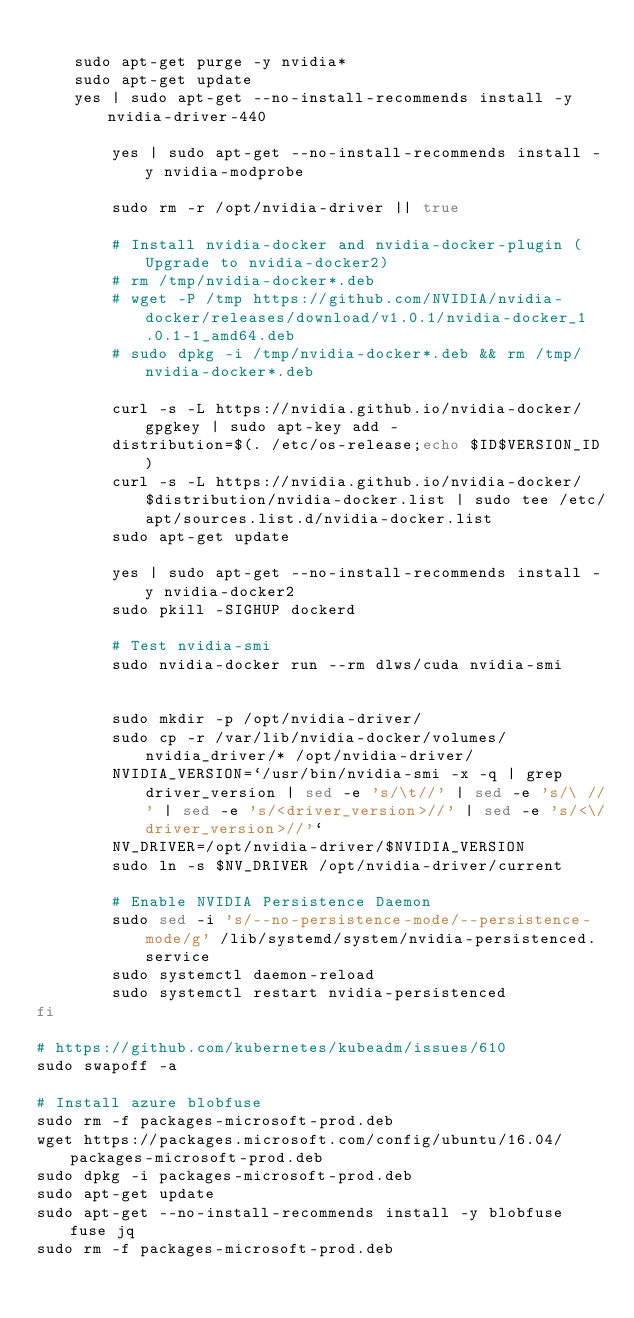<code> <loc_0><loc_0><loc_500><loc_500><_Bash_>
    sudo apt-get purge -y nvidia*
    sudo apt-get update
    yes | sudo apt-get --no-install-recommends install -y nvidia-driver-440

        yes | sudo apt-get --no-install-recommends install -y nvidia-modprobe

        sudo rm -r /opt/nvidia-driver || true

        # Install nvidia-docker and nvidia-docker-plugin ( Upgrade to nvidia-docker2)
        # rm /tmp/nvidia-docker*.deb
        # wget -P /tmp https://github.com/NVIDIA/nvidia-docker/releases/download/v1.0.1/nvidia-docker_1.0.1-1_amd64.deb
        # sudo dpkg -i /tmp/nvidia-docker*.deb && rm /tmp/nvidia-docker*.deb

        curl -s -L https://nvidia.github.io/nvidia-docker/gpgkey | sudo apt-key add -
        distribution=$(. /etc/os-release;echo $ID$VERSION_ID)
        curl -s -L https://nvidia.github.io/nvidia-docker/$distribution/nvidia-docker.list | sudo tee /etc/apt/sources.list.d/nvidia-docker.list
        sudo apt-get update

        yes | sudo apt-get --no-install-recommends install -y nvidia-docker2
        sudo pkill -SIGHUP dockerd

        # Test nvidia-smi
        sudo nvidia-docker run --rm dlws/cuda nvidia-smi


        sudo mkdir -p /opt/nvidia-driver/
        sudo cp -r /var/lib/nvidia-docker/volumes/nvidia_driver/* /opt/nvidia-driver/
        NVIDIA_VERSION=`/usr/bin/nvidia-smi -x -q | grep driver_version | sed -e 's/\t//' | sed -e 's/\ //' | sed -e 's/<driver_version>//' | sed -e 's/<\/driver_version>//'`
        NV_DRIVER=/opt/nvidia-driver/$NVIDIA_VERSION
        sudo ln -s $NV_DRIVER /opt/nvidia-driver/current

        # Enable NVIDIA Persistence Daemon
        sudo sed -i 's/--no-persistence-mode/--persistence-mode/g' /lib/systemd/system/nvidia-persistenced.service
        sudo systemctl daemon-reload
        sudo systemctl restart nvidia-persistenced
fi

# https://github.com/kubernetes/kubeadm/issues/610
sudo swapoff -a

# Install azure blobfuse
sudo rm -f packages-microsoft-prod.deb
wget https://packages.microsoft.com/config/ubuntu/16.04/packages-microsoft-prod.deb
sudo dpkg -i packages-microsoft-prod.deb
sudo apt-get update
sudo apt-get --no-install-recommends install -y blobfuse fuse jq
sudo rm -f packages-microsoft-prod.deb</code> 